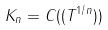Convert formula to latex. <formula><loc_0><loc_0><loc_500><loc_500>K _ { n } = C ( ( T ^ { 1 / n } ) )</formula> 